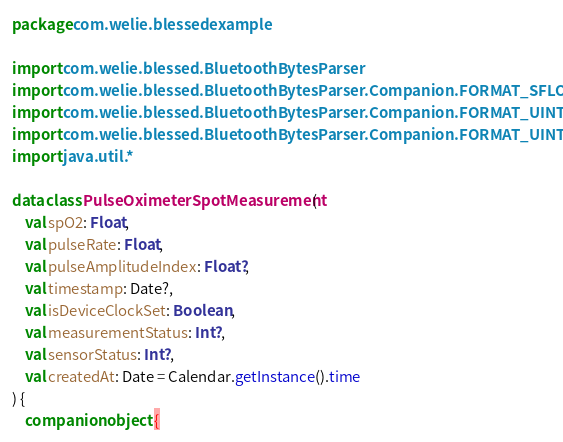<code> <loc_0><loc_0><loc_500><loc_500><_Kotlin_>package com.welie.blessedexample

import com.welie.blessed.BluetoothBytesParser
import com.welie.blessed.BluetoothBytesParser.Companion.FORMAT_SFLOAT
import com.welie.blessed.BluetoothBytesParser.Companion.FORMAT_UINT16
import com.welie.blessed.BluetoothBytesParser.Companion.FORMAT_UINT8
import java.util.*

data class PulseOximeterSpotMeasurement(
    val spO2: Float,
    val pulseRate: Float,
    val pulseAmplitudeIndex: Float?,
    val timestamp: Date?,
    val isDeviceClockSet: Boolean,
    val measurementStatus: Int?,
    val sensorStatus: Int?,
    val createdAt: Date = Calendar.getInstance().time
) {
    companion object {</code> 